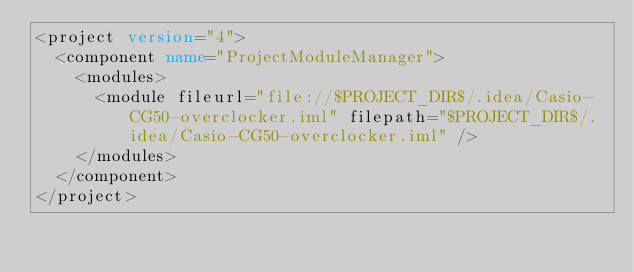<code> <loc_0><loc_0><loc_500><loc_500><_XML_><project version="4">
  <component name="ProjectModuleManager">
    <modules>
      <module fileurl="file://$PROJECT_DIR$/.idea/Casio-CG50-overclocker.iml" filepath="$PROJECT_DIR$/.idea/Casio-CG50-overclocker.iml" />
    </modules>
  </component>
</project></code> 